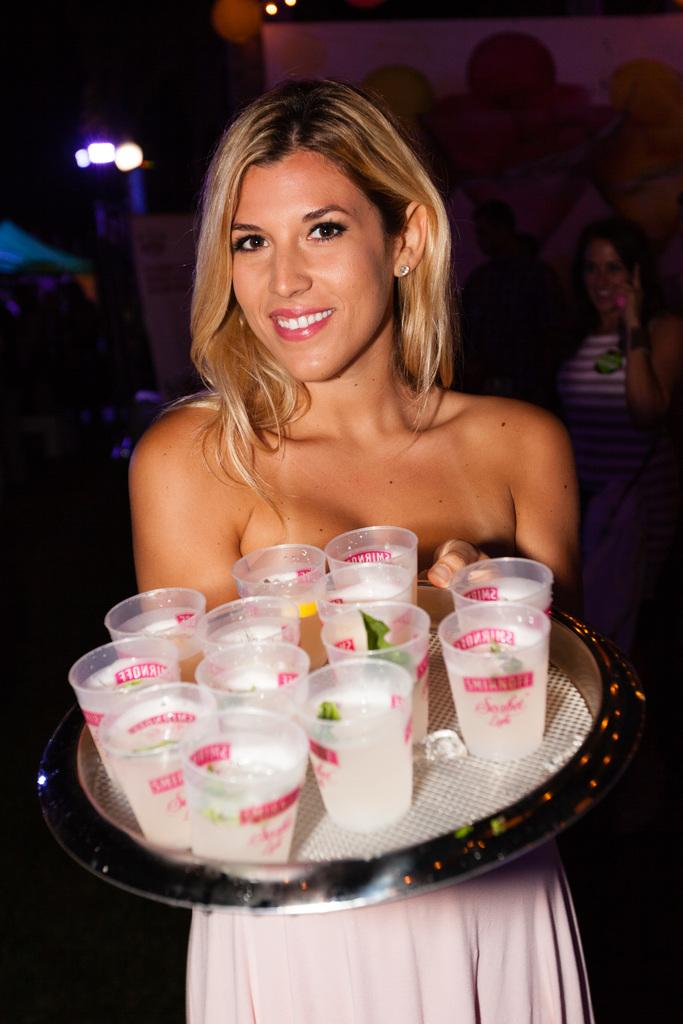What is the person holding in the image? The person is holding a plate in the image. What is on the plate that the person is holding? The plate contains juice glasses. Can you describe the people behind the person holding the plate? There are people visible behind the person holding the plate. What type of illumination is present in the image? There are lights visible in the image. What device can be seen in the image that is typically used for projecting images or videos? There is a projector in the image. What direction is the person flying in the image? There is no person flying in the image; the person is holding a plate with juice glasses. 